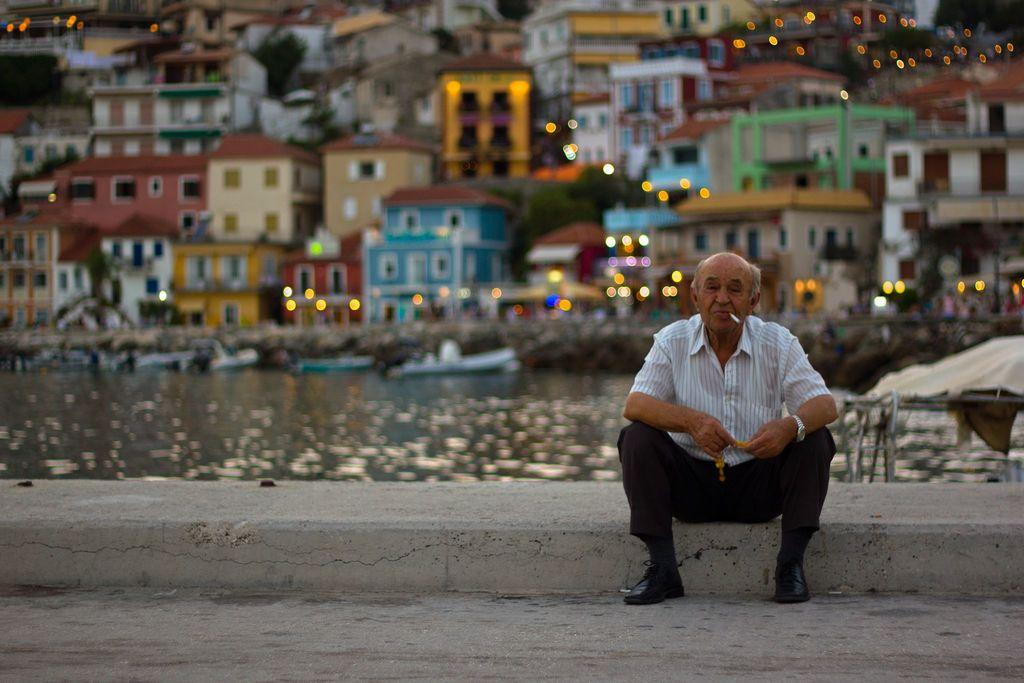What type of structures can be seen in the image? There are buildings in the image. What is located near the buildings? There are boats in the water in the image. What can be seen illuminated in the image? There are lights visible in the image. What is the man in the image doing? The man is seated in the image, and he has a cigarette in his mouth. What is the man holding in his hand? The man is holding something in his hand, but the specific object is not clear from the image. What type of prison can be seen in the image? There is no prison present in the image. What type of basin is visible in the image? There is no basin present in the image. 